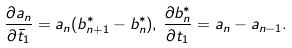<formula> <loc_0><loc_0><loc_500><loc_500>\frac { \partial a _ { n } } { \partial \bar { t } _ { 1 } } = a _ { n } ( b _ { n + 1 } ^ { * } - b _ { n } ^ { * } ) , \, \frac { \partial b _ { n } ^ { * } } { \partial t _ { 1 } } = a _ { n } - a _ { n - 1 } .</formula> 